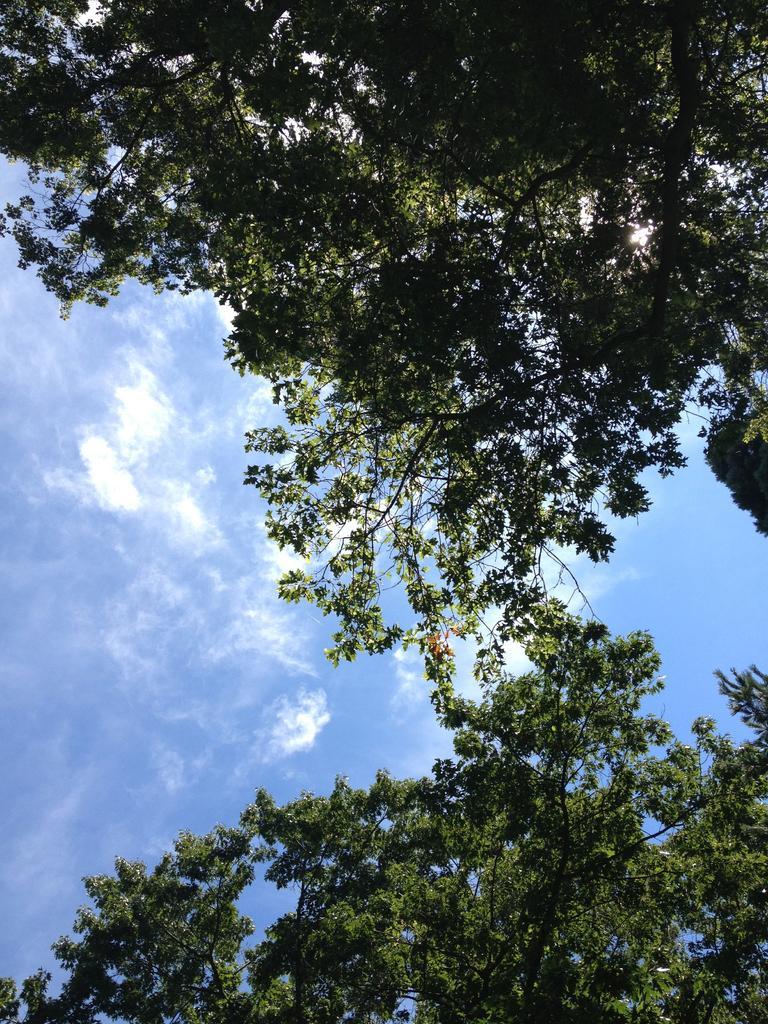Describe this image in one or two sentences. In the image we can see some trees. Behind the trees there are some clouds and sky. 